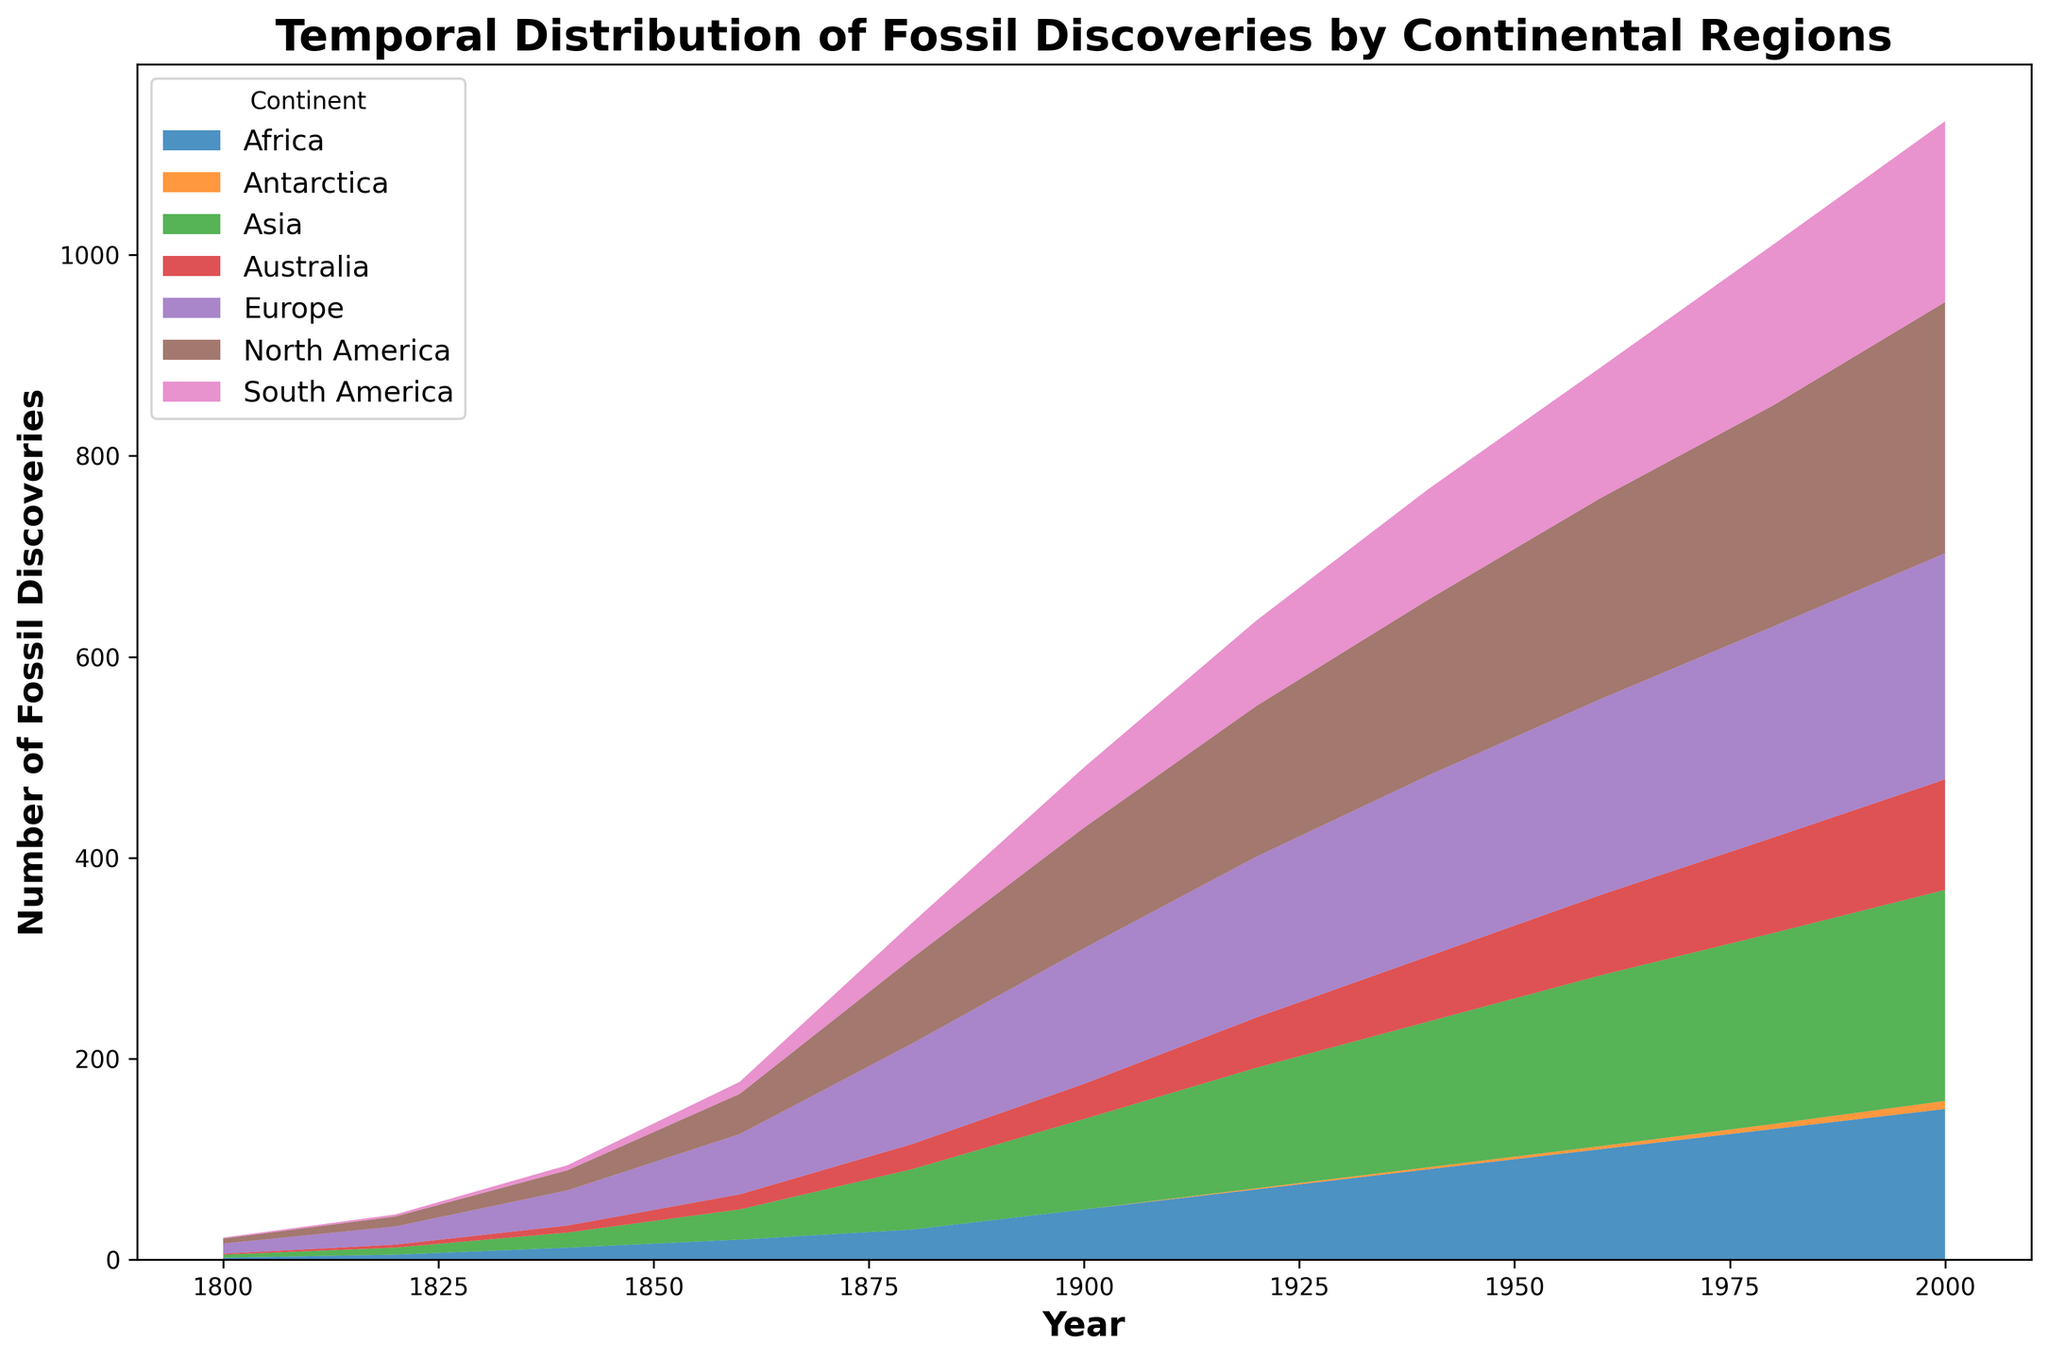How many fossil discoveries were there in North America in 2000? By looking at the year 2000 on the x-axis and following upwards to the topmost layer corresponding to North America, the number can be directly read off the y-axis or legend.
Answer: 250 Which continent shows the smallest number of fossil discoveries in 1800? By looking at the beginning of the timeline at the year 1800, the smallest visible area corresponds to South America and Australia, both having only 1 discovery.
Answer: South America and Australia Between 1920 and 1960, which continent showed the largest increase in fossil discoveries? By comparing the size of the stacked areas on the chart between 1920 and 1960, North America shows the largest increase, as its area expanded significantly compared to other continents in that period.
Answer: North America Compare the number of fossil discoveries in Europe and Africa in 1940. Which continent had more? By looking at the year 1940 and comparing the heights of the segments for Europe and Africa, Europe had more, with the segment representing Europe being higher than Africa's.
Answer: Europe What is the cumulative number of fossil discoveries in Asia and Australia in 2000? From the year 2000, adding the fossil discoveries for Asia (210) and Australia (110) results in the sum 210 + 110.
Answer: 320 How many steps are needed to answer the question: "Which continent had the highest number of total fossil discoveries by 2000?" First, identify the year 2000 in the plot, then assess the height of each region's segment at this year. The tallest segment will indicate the highest number of discoveries. North America's region is the tallest.
Answer: North America Compare the fossil discoveries in Antarctica in 1920 and 2000. How has the number changed? By looking at the respective years on the x-axis and noting the height of the segment corresponding to Antarctica, you can compare the values: 1 in 1920 and 8 in 2000. The change is an increase.
Answer: Increased by 7 Sum the fossil discoveries from continents with at least 100 fossil discoveries by 1900. What is the total? From the chart, by 1900, North America had 120 discoveries and Europe had 135, while other continents had less than 100. Sum these values: 120 + 135.
Answer: 255 Which continent's fossil discoveries show a steady and significant rise from 1800 to 2000? By examining the trends of the different areas over time, North America's area shows a steady and continuous rise from 1800 to 2000, unlike other continents which may show more fluctuations.
Answer: North America 